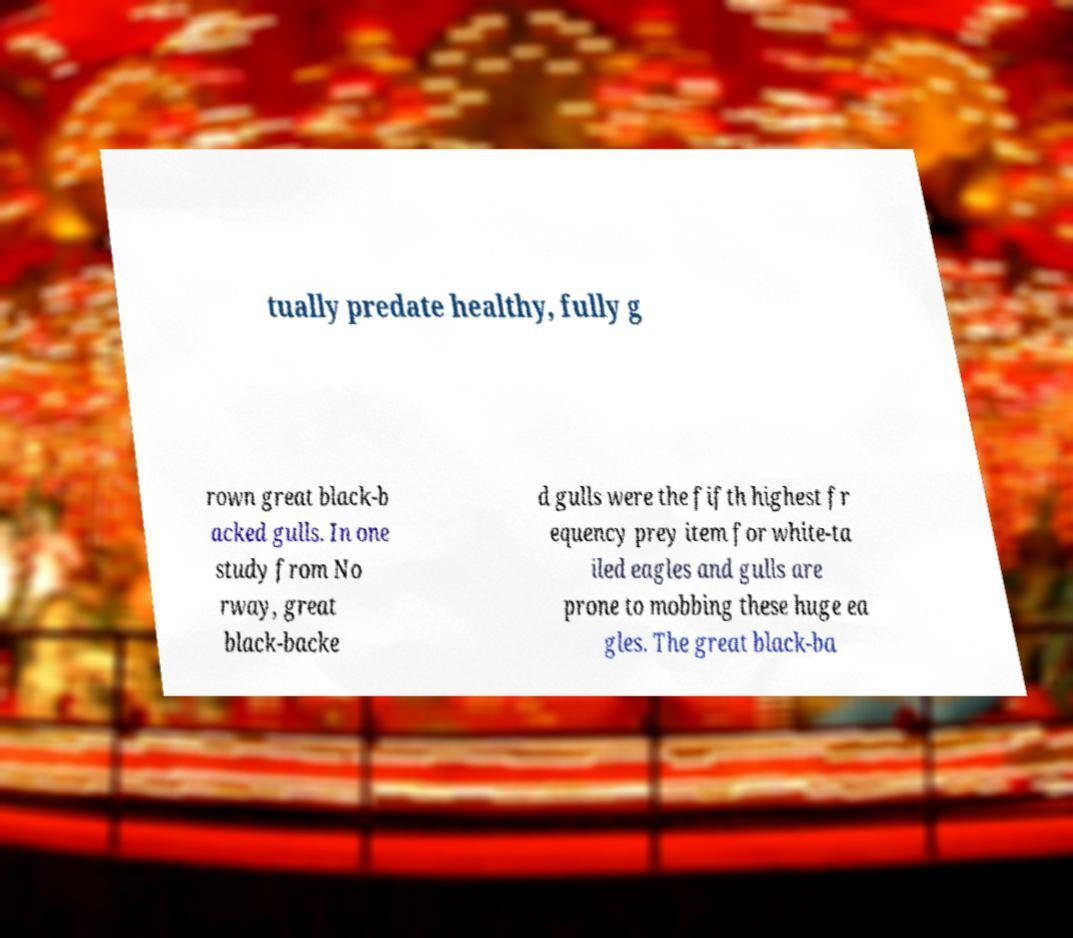I need the written content from this picture converted into text. Can you do that? tually predate healthy, fully g rown great black-b acked gulls. In one study from No rway, great black-backe d gulls were the fifth highest fr equency prey item for white-ta iled eagles and gulls are prone to mobbing these huge ea gles. The great black-ba 